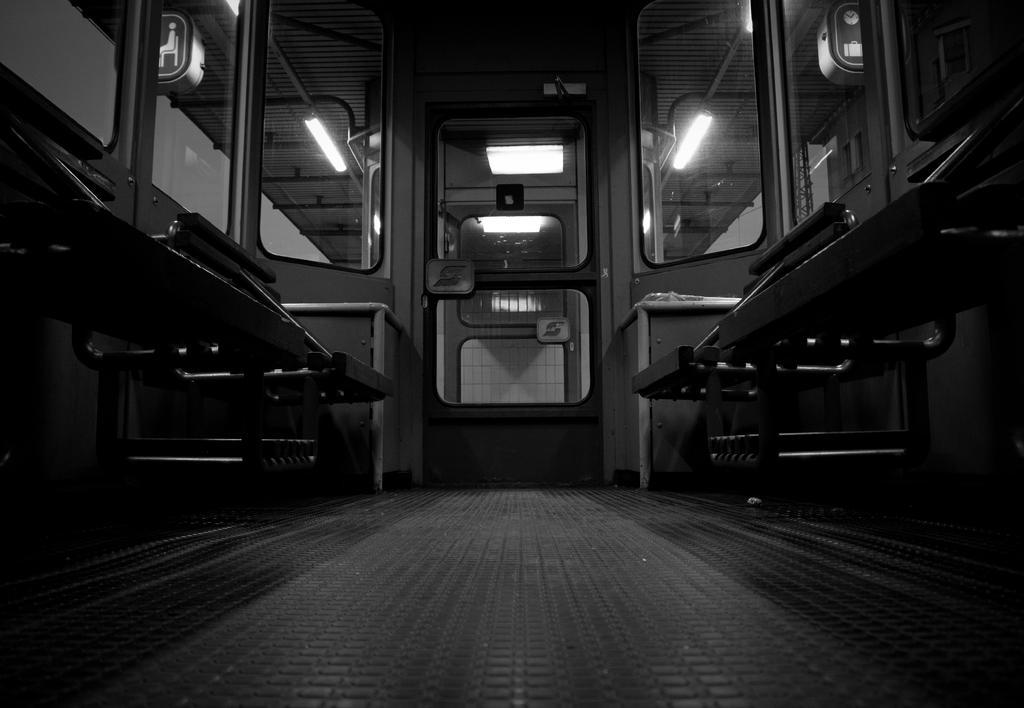How would you summarize this image in a sentence or two? In this picture I can observe an inside view of a train. On either sides of the picture I can observe seats. In the middle of the picture I can observe door. In the background there are lights fixed to the ceiling. 